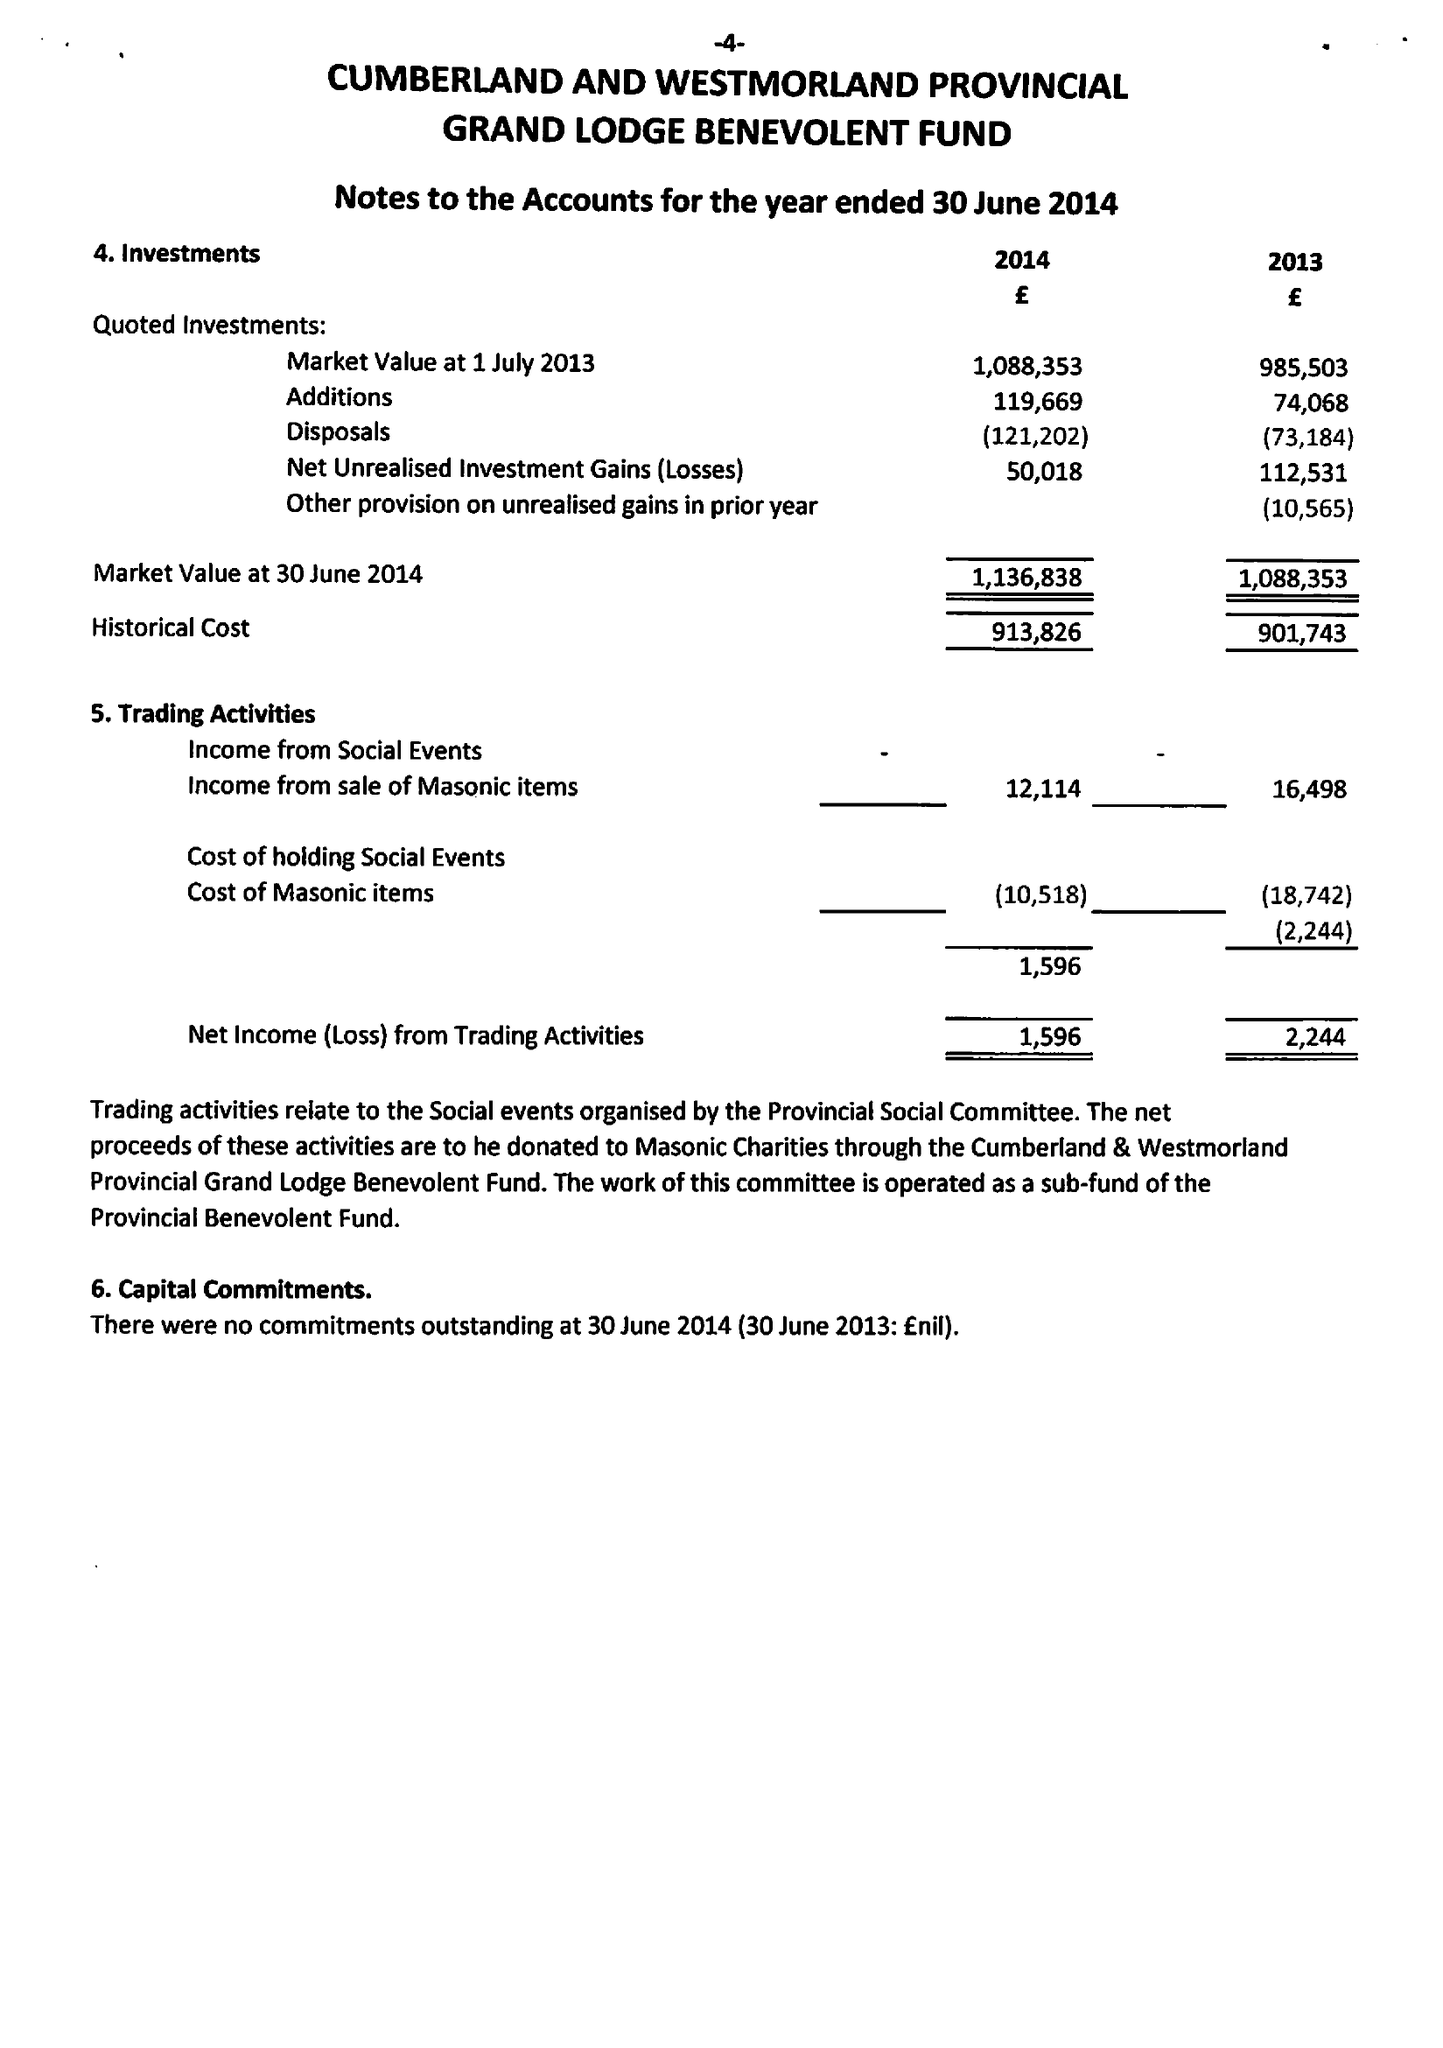What is the value for the income_annually_in_british_pounds?
Answer the question using a single word or phrase. 106486.00 